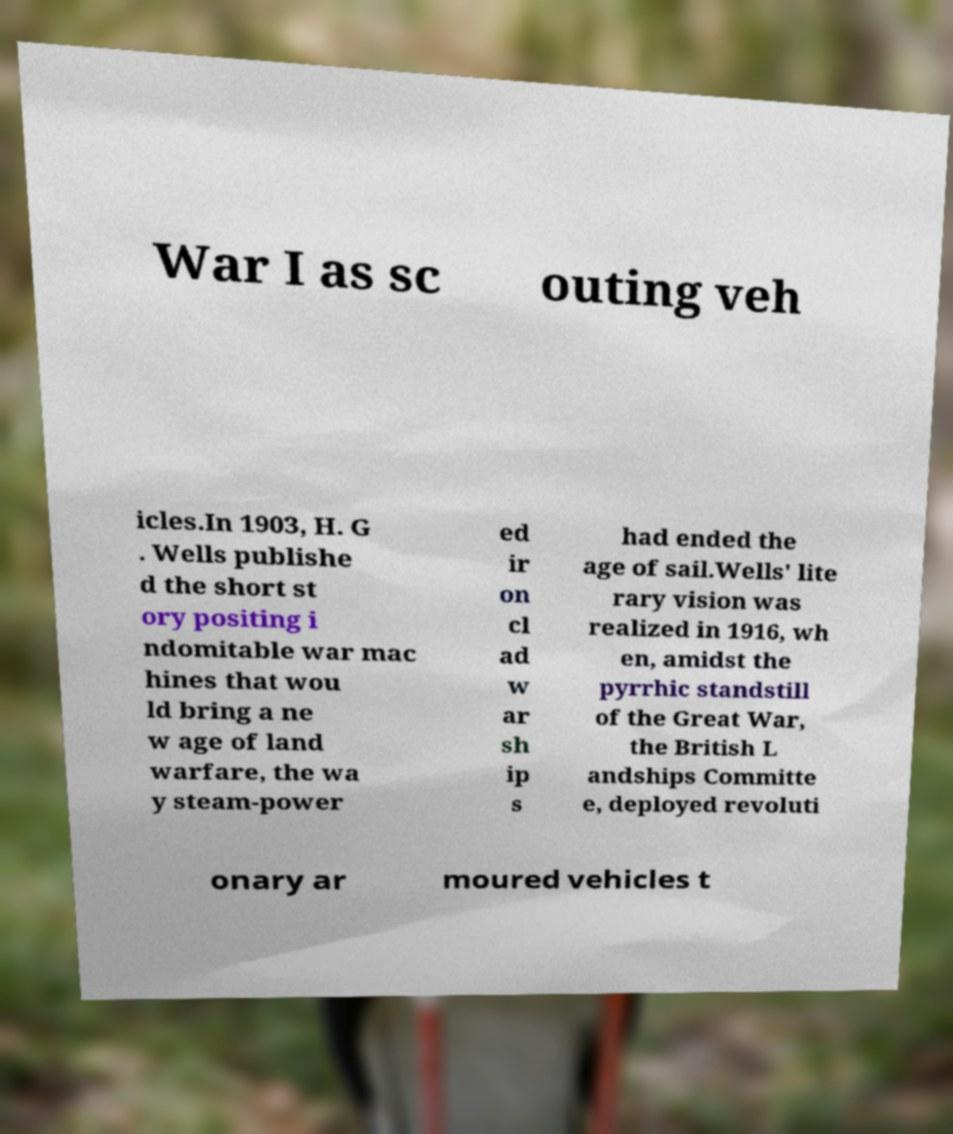Could you extract and type out the text from this image? War I as sc outing veh icles.In 1903, H. G . Wells publishe d the short st ory positing i ndomitable war mac hines that wou ld bring a ne w age of land warfare, the wa y steam-power ed ir on cl ad w ar sh ip s had ended the age of sail.Wells' lite rary vision was realized in 1916, wh en, amidst the pyrrhic standstill of the Great War, the British L andships Committe e, deployed revoluti onary ar moured vehicles t 